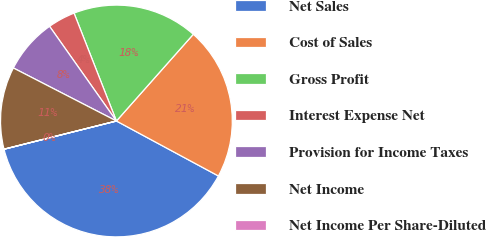<chart> <loc_0><loc_0><loc_500><loc_500><pie_chart><fcel>Net Sales<fcel>Cost of Sales<fcel>Gross Profit<fcel>Interest Expense Net<fcel>Provision for Income Taxes<fcel>Net Income<fcel>Net Income Per Share-Diluted<nl><fcel>38.21%<fcel>21.32%<fcel>17.5%<fcel>3.83%<fcel>7.65%<fcel>11.47%<fcel>0.01%<nl></chart> 